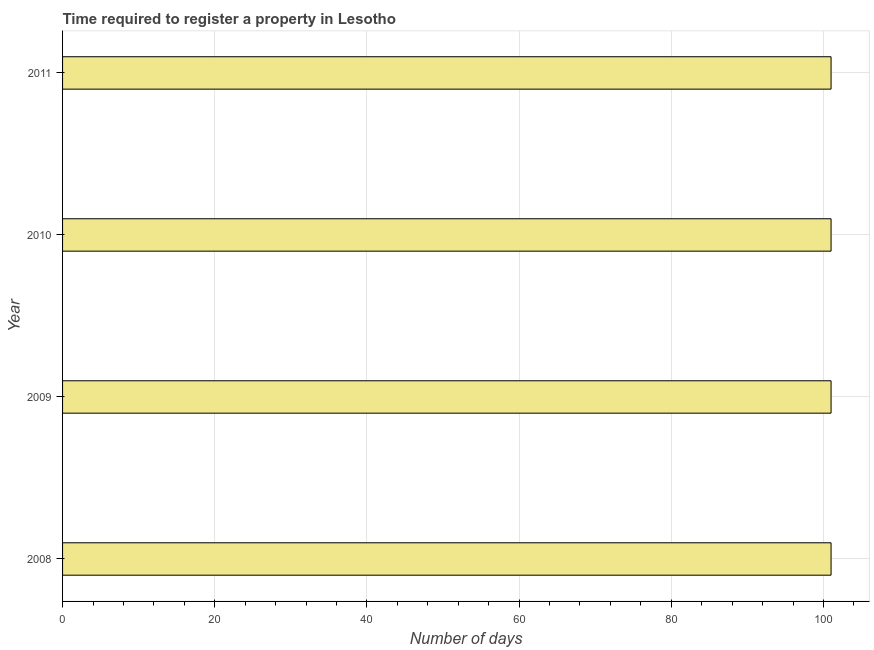Does the graph contain grids?
Ensure brevity in your answer.  Yes. What is the title of the graph?
Offer a terse response. Time required to register a property in Lesotho. What is the label or title of the X-axis?
Keep it short and to the point. Number of days. What is the number of days required to register property in 2010?
Ensure brevity in your answer.  101. Across all years, what is the maximum number of days required to register property?
Give a very brief answer. 101. Across all years, what is the minimum number of days required to register property?
Your answer should be very brief. 101. What is the sum of the number of days required to register property?
Provide a succinct answer. 404. What is the difference between the number of days required to register property in 2009 and 2011?
Provide a succinct answer. 0. What is the average number of days required to register property per year?
Make the answer very short. 101. What is the median number of days required to register property?
Provide a succinct answer. 101. In how many years, is the number of days required to register property greater than 8 days?
Give a very brief answer. 4. Do a majority of the years between 2009 and 2010 (inclusive) have number of days required to register property greater than 64 days?
Keep it short and to the point. Yes. What is the ratio of the number of days required to register property in 2009 to that in 2010?
Offer a terse response. 1. Is the number of days required to register property in 2008 less than that in 2011?
Your answer should be compact. No. Is the difference between the number of days required to register property in 2010 and 2011 greater than the difference between any two years?
Give a very brief answer. Yes. What is the difference between the highest and the second highest number of days required to register property?
Offer a terse response. 0. What is the difference between the highest and the lowest number of days required to register property?
Offer a terse response. 0. What is the Number of days of 2008?
Your response must be concise. 101. What is the Number of days in 2009?
Provide a succinct answer. 101. What is the Number of days of 2010?
Keep it short and to the point. 101. What is the Number of days in 2011?
Keep it short and to the point. 101. What is the difference between the Number of days in 2008 and 2010?
Give a very brief answer. 0. What is the difference between the Number of days in 2008 and 2011?
Offer a terse response. 0. What is the difference between the Number of days in 2010 and 2011?
Your response must be concise. 0. What is the ratio of the Number of days in 2008 to that in 2011?
Your response must be concise. 1. What is the ratio of the Number of days in 2009 to that in 2010?
Offer a very short reply. 1. 